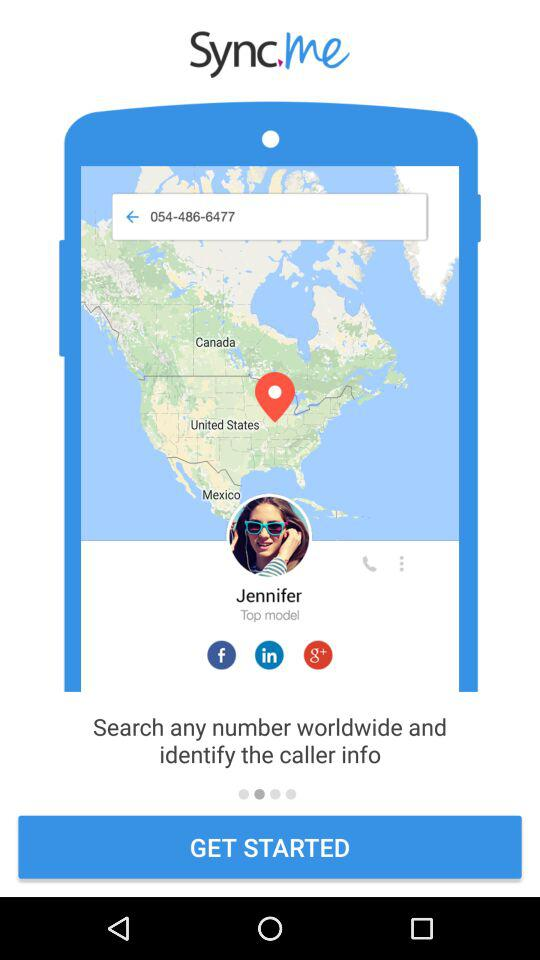What is the name of the application? The application name is "Sync me". 